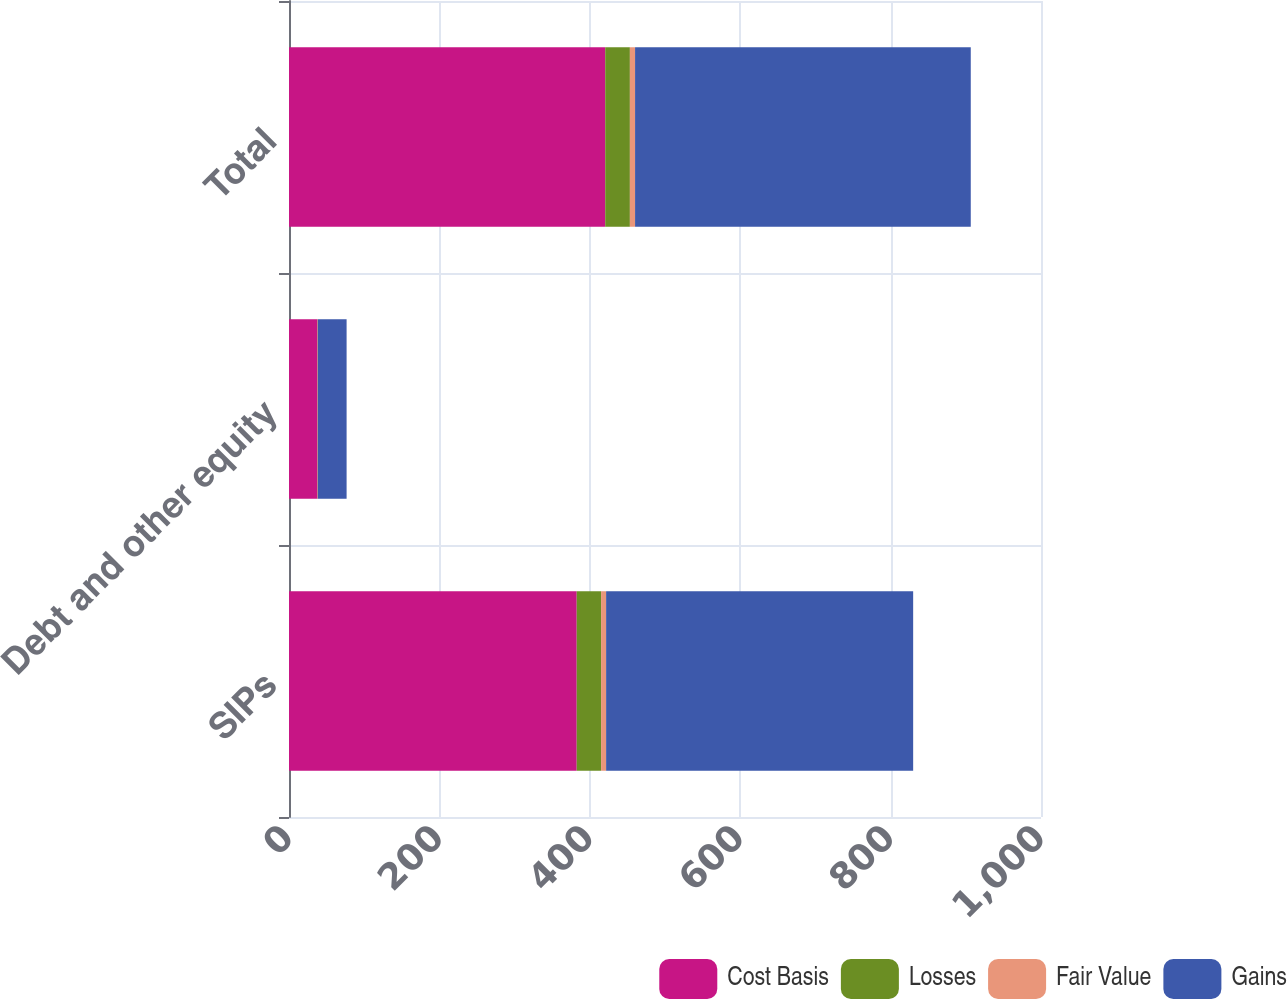Convert chart to OTSL. <chart><loc_0><loc_0><loc_500><loc_500><stacked_bar_chart><ecel><fcel>SIPs<fcel>Debt and other equity<fcel>Total<nl><fcel>Cost Basis<fcel>382.6<fcel>37.9<fcel>420.5<nl><fcel>Losses<fcel>32.4<fcel>0.4<fcel>32.8<nl><fcel>Fair Value<fcel>6.7<fcel>0.2<fcel>6.9<nl><fcel>Gains<fcel>408.3<fcel>38.1<fcel>446.4<nl></chart> 